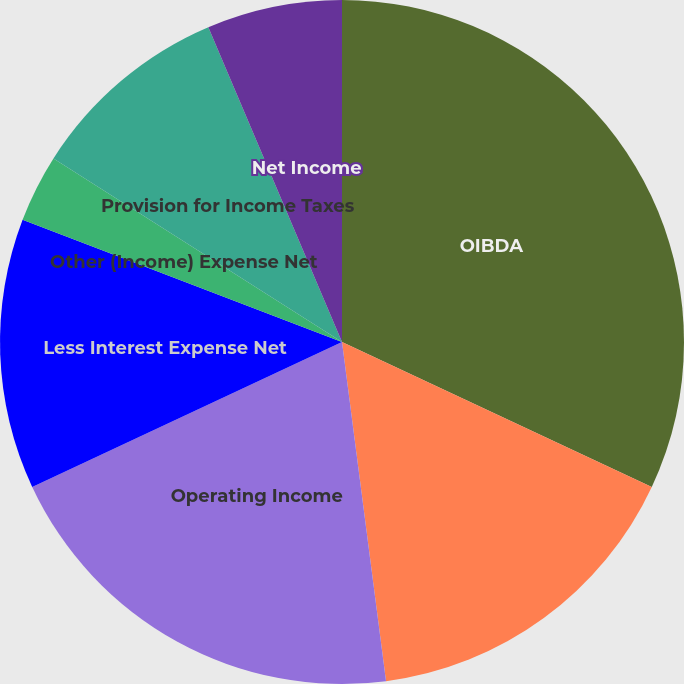Convert chart. <chart><loc_0><loc_0><loc_500><loc_500><pie_chart><fcel>OIBDA<fcel>Less Depreciation and<fcel>Operating Income<fcel>Less Interest Expense Net<fcel>Other (Income) Expense Net<fcel>Provision for Income Taxes<fcel>Minority Interest in Earnings<fcel>Net Income<nl><fcel>31.96%<fcel>15.98%<fcel>20.09%<fcel>12.78%<fcel>3.2%<fcel>9.59%<fcel>0.0%<fcel>6.39%<nl></chart> 